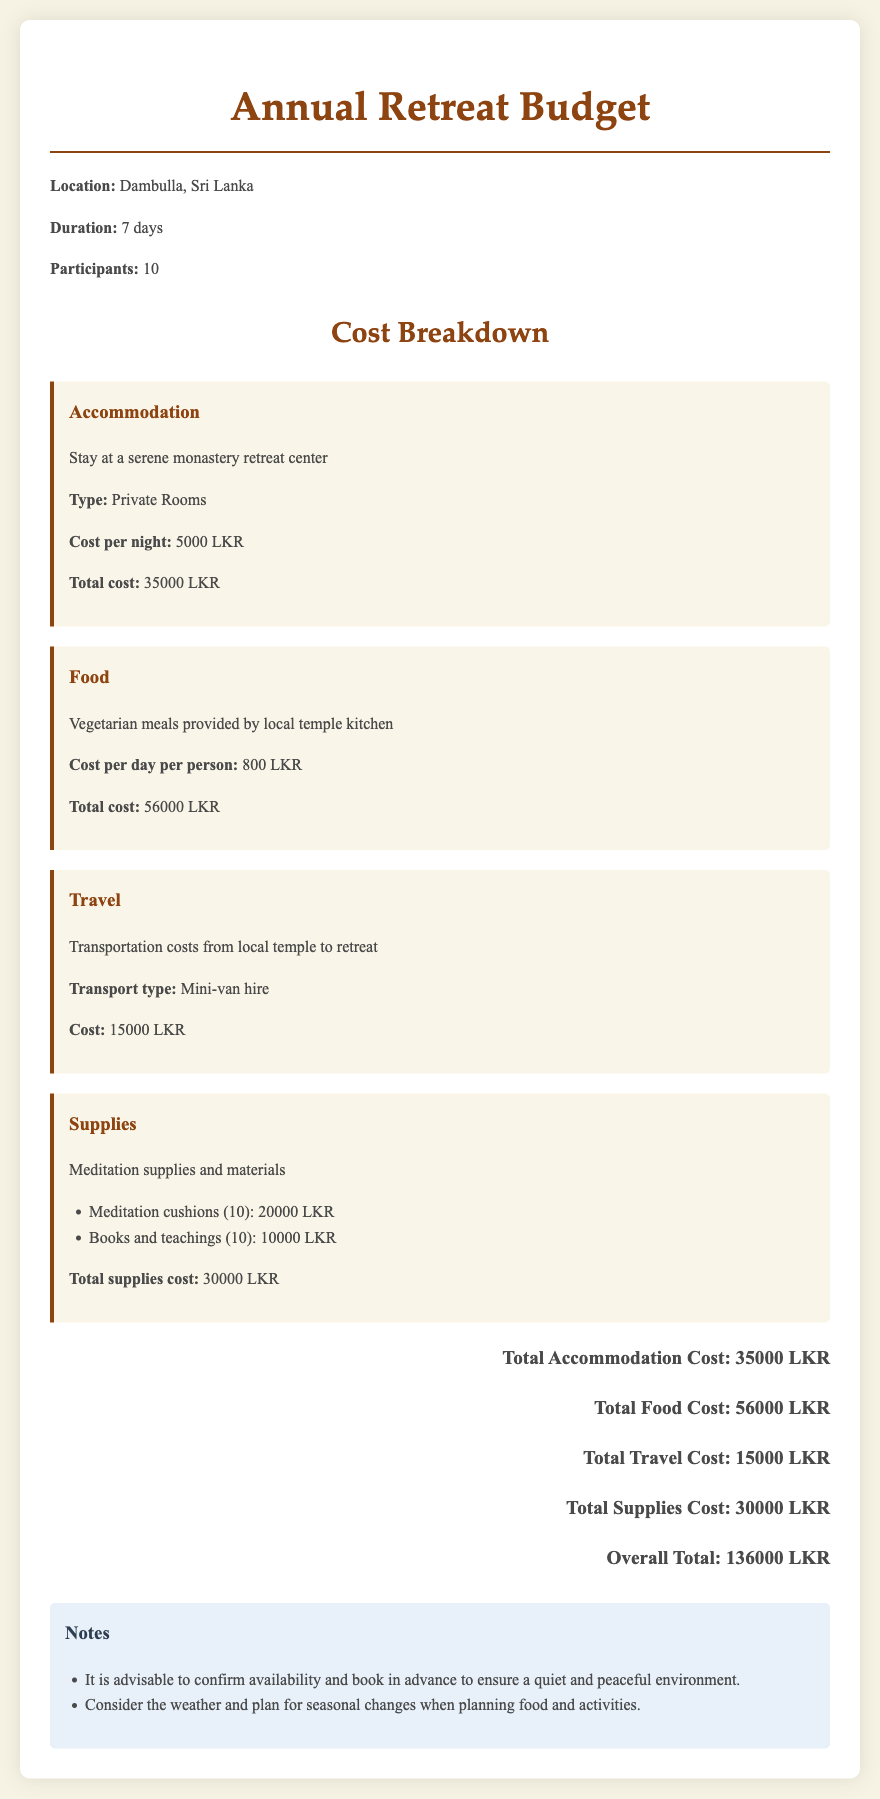What is the total cost of accommodation? The total cost of accommodation is stated in the document as 35000 LKR.
Answer: 35000 LKR What type of meals are provided during the retreat? The document mentions that vegetarian meals are provided by the local temple kitchen.
Answer: Vegetarian How many days will the retreat last? The duration of the retreat is explicitly mentioned as 7 days.
Answer: 7 days What is the cost per day for food per person? The document specifies the cost per day per person for food as 800 LKR.
Answer: 800 LKR What transportation type is hired for travel? The document states that a mini-van is hired for transportation.
Answer: Mini-van What is the total cost for supplies? The overall total for supplies is provided as 30000 LKR in the budget.
Answer: 30000 LKR How many participants are there for the retreat? The number of participants is noted in the document as 10.
Answer: 10 What is the overall total budget for the retreat? The document summarizes the overall total budget as 136000 LKR.
Answer: 136000 LKR What should be confirmed before booking the retreat? The document advises to confirm availability before booking to ensure a peaceful environment.
Answer: Availability 